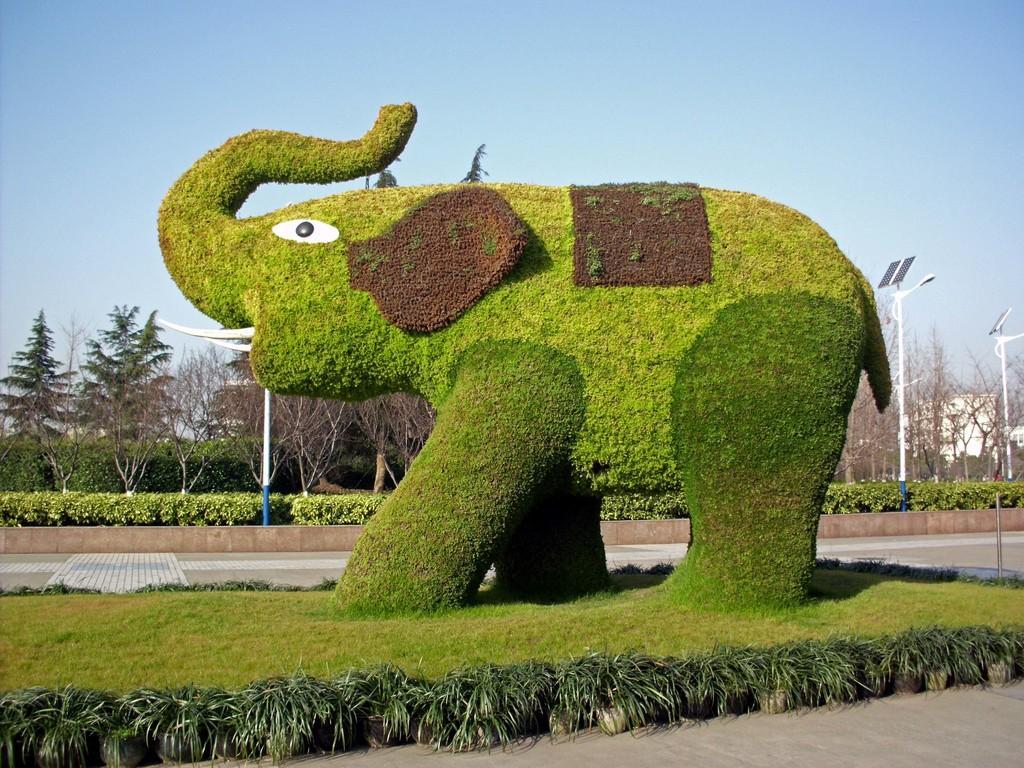In one or two sentences, can you explain what this image depicts? In this image there is a statue of an elephant in the center. On the right side there are poles, there are dry trees, and plants. In the front on the ground there is grass. In the background there are trees, plants, and there is a pole. 